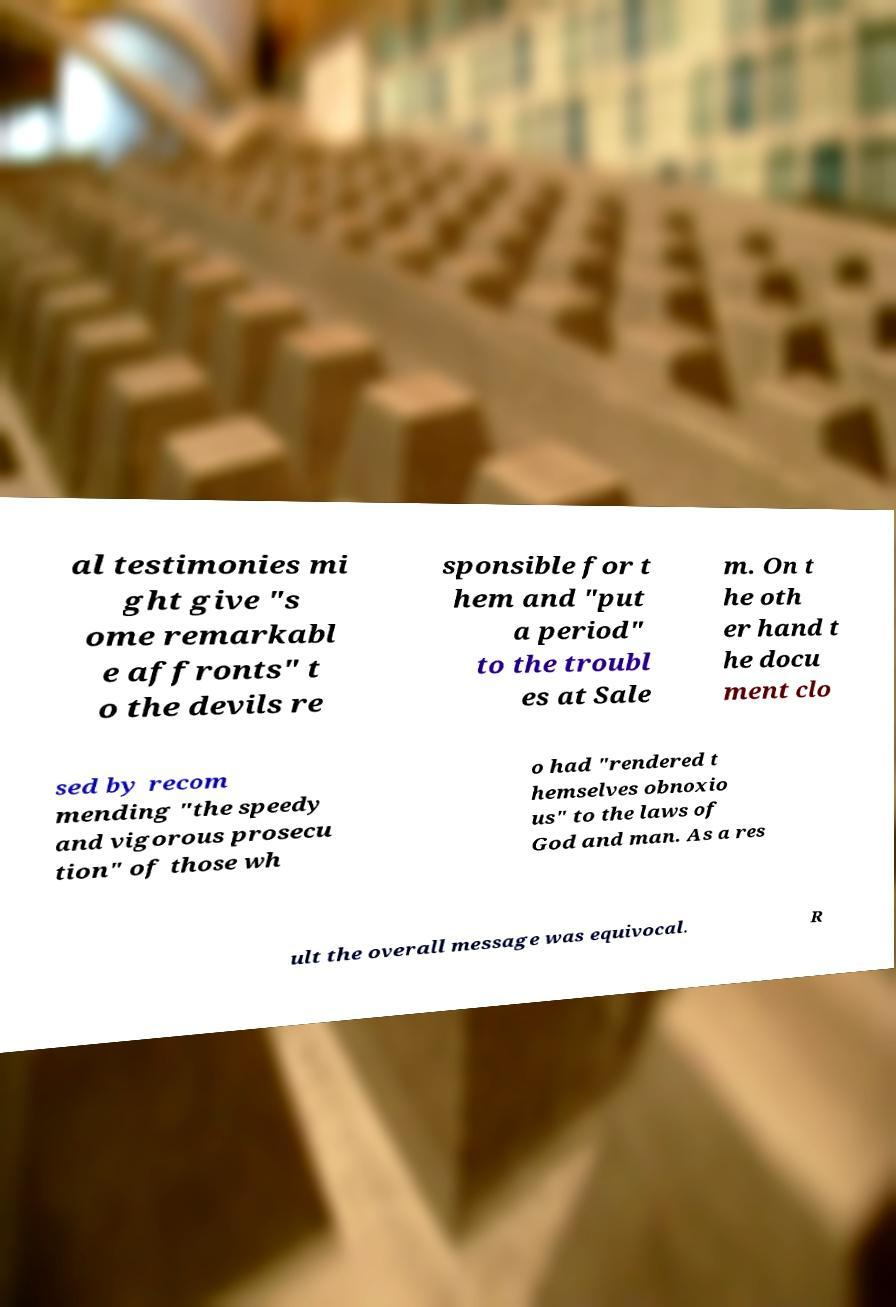Could you assist in decoding the text presented in this image and type it out clearly? al testimonies mi ght give "s ome remarkabl e affronts" t o the devils re sponsible for t hem and "put a period" to the troubl es at Sale m. On t he oth er hand t he docu ment clo sed by recom mending "the speedy and vigorous prosecu tion" of those wh o had "rendered t hemselves obnoxio us" to the laws of God and man. As a res ult the overall message was equivocal. R 